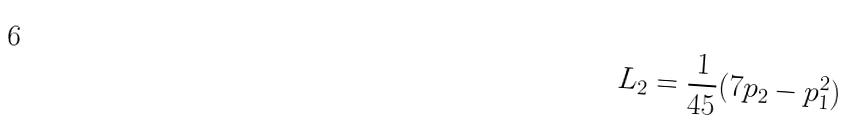<formula> <loc_0><loc_0><loc_500><loc_500>L _ { 2 } = \frac { 1 } { 4 5 } ( 7 p _ { 2 } - p _ { 1 } ^ { 2 } )</formula> 